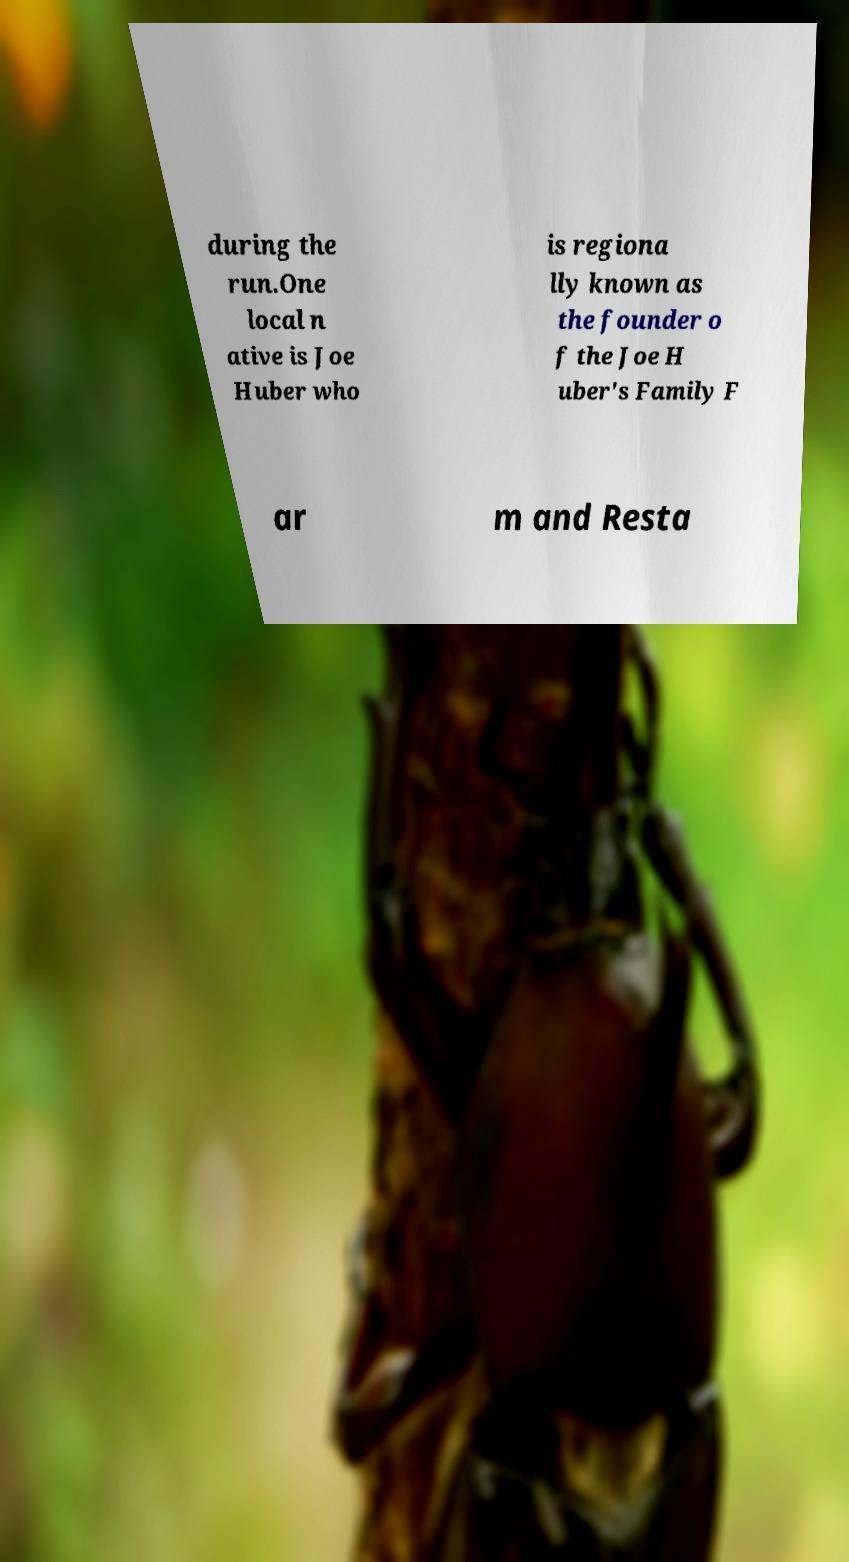Can you read and provide the text displayed in the image?This photo seems to have some interesting text. Can you extract and type it out for me? during the run.One local n ative is Joe Huber who is regiona lly known as the founder o f the Joe H uber's Family F ar m and Resta 